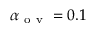Convert formula to latex. <formula><loc_0><loc_0><loc_500><loc_500>\alpha _ { o v } = 0 . 1</formula> 